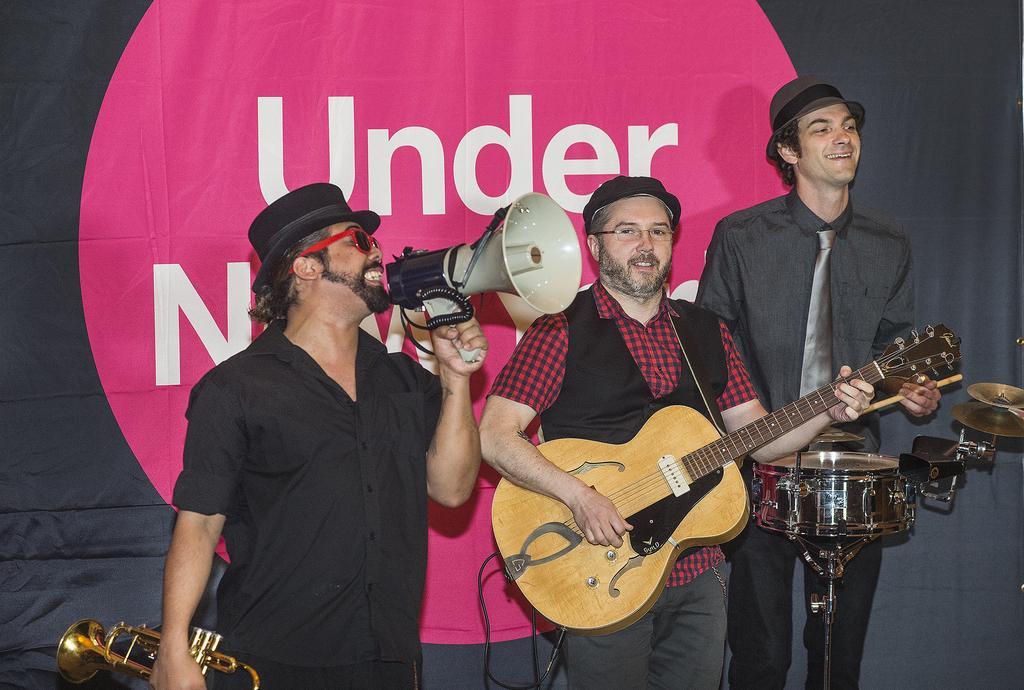How would you summarize this image in a sentence or two? This is the image of a man who is shouting in the speaker by wearing a black color hat , red color spectacles by holding the saxophone and next to him there is another man who is playing guitar by holding in his hand and there is another man who is standing and smiling by playing the drums and at the back ground there is a banner with some words. 